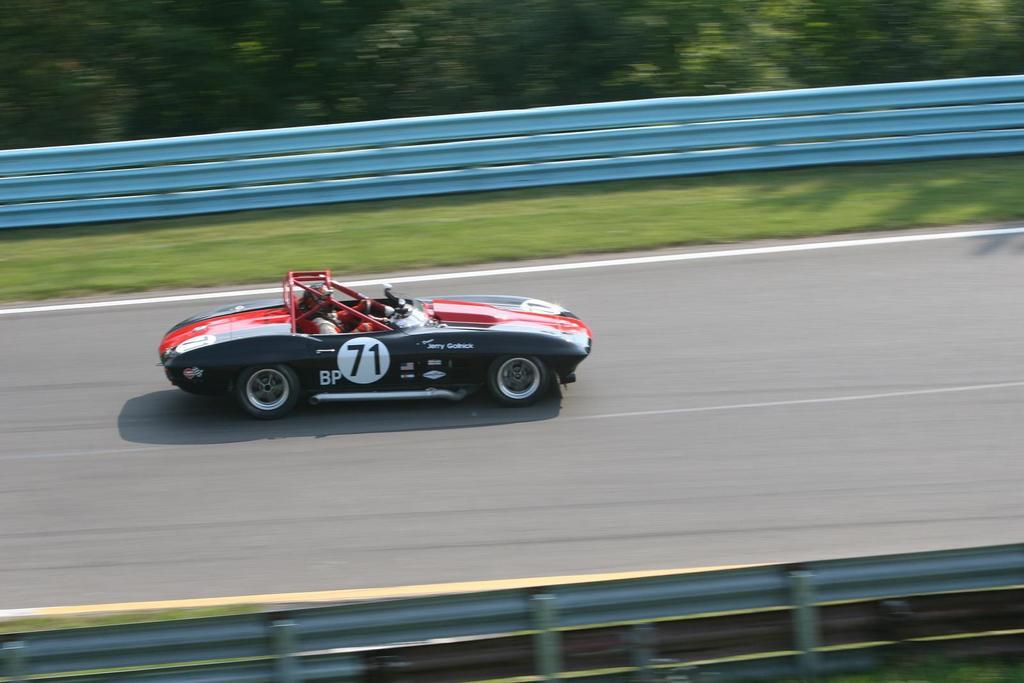What is the person in the image doing? There is a person riding a sports car in the image. Where is the sports car located? The sports car is on the road. What type of vegetation can be seen in the image? There is grass visible in the image. What is the barrier between the road and the grass? There is a fence in the image. What else can be seen in the background of the image? There are trees in the image. What type of grain is being harvested by the lawyer in the image? There is no lawyer or grain present in the image. Is there any blood visible on the sports car in the image? There is no blood visible on the sports car or anywhere else in the image. 